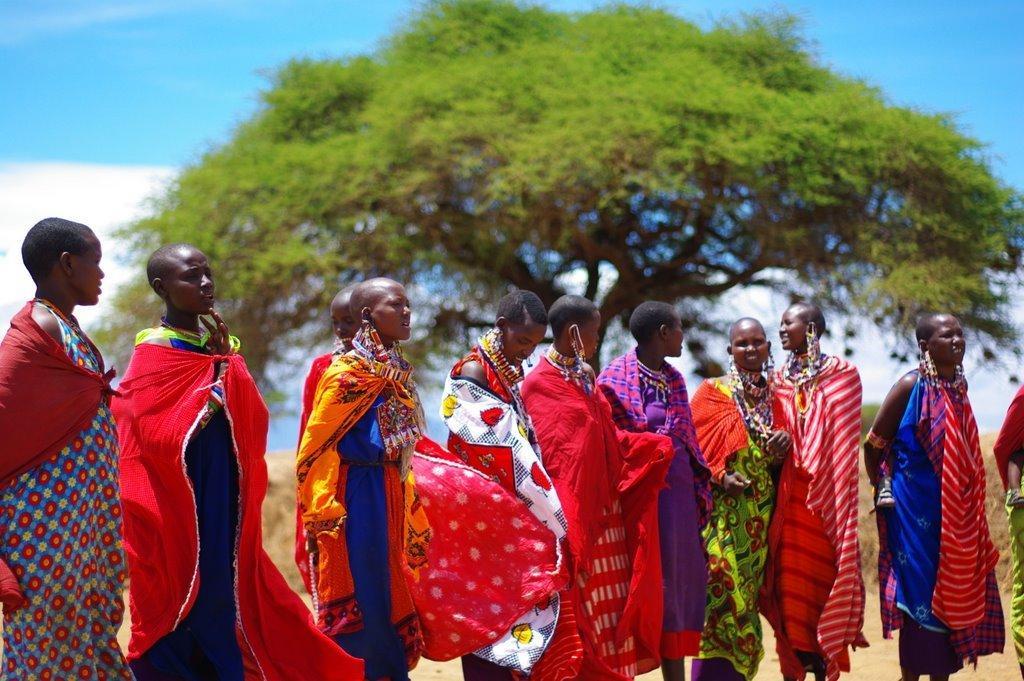Describe this image in one or two sentences. In this picture we can see a group of people standing from left to right. We can see a tree in the background. Sky is blue in color and cloudy. 